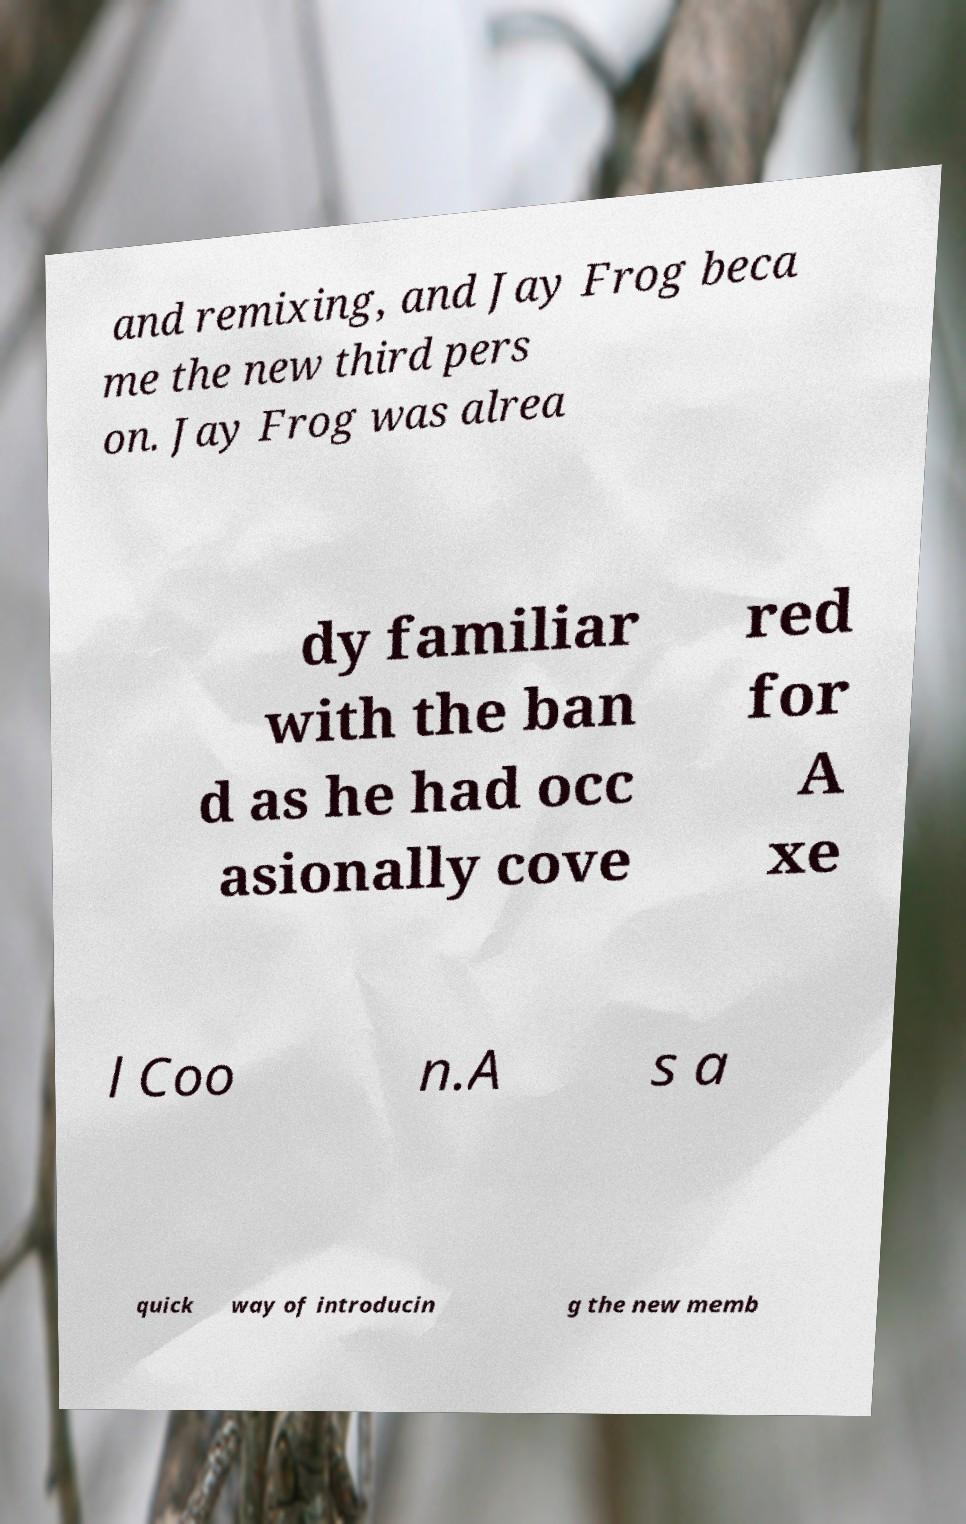Can you accurately transcribe the text from the provided image for me? and remixing, and Jay Frog beca me the new third pers on. Jay Frog was alrea dy familiar with the ban d as he had occ asionally cove red for A xe l Coo n.A s a quick way of introducin g the new memb 